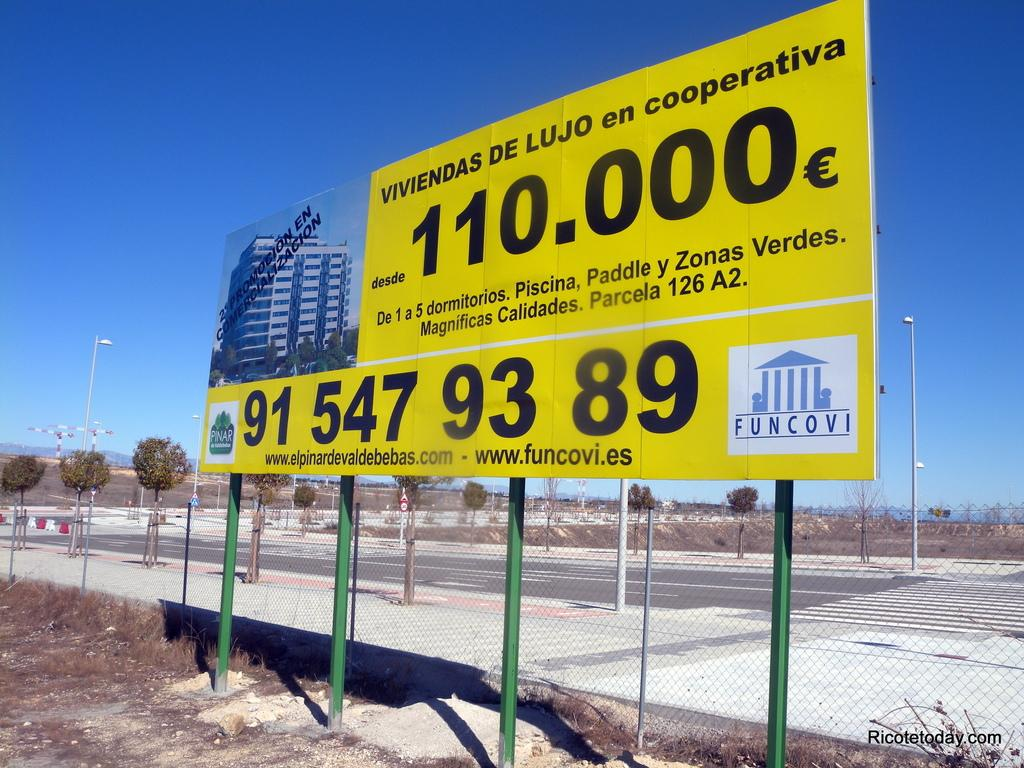<image>
Offer a succinct explanation of the picture presented. The Funcovi logo occupies the corner of a construction project billboard. 